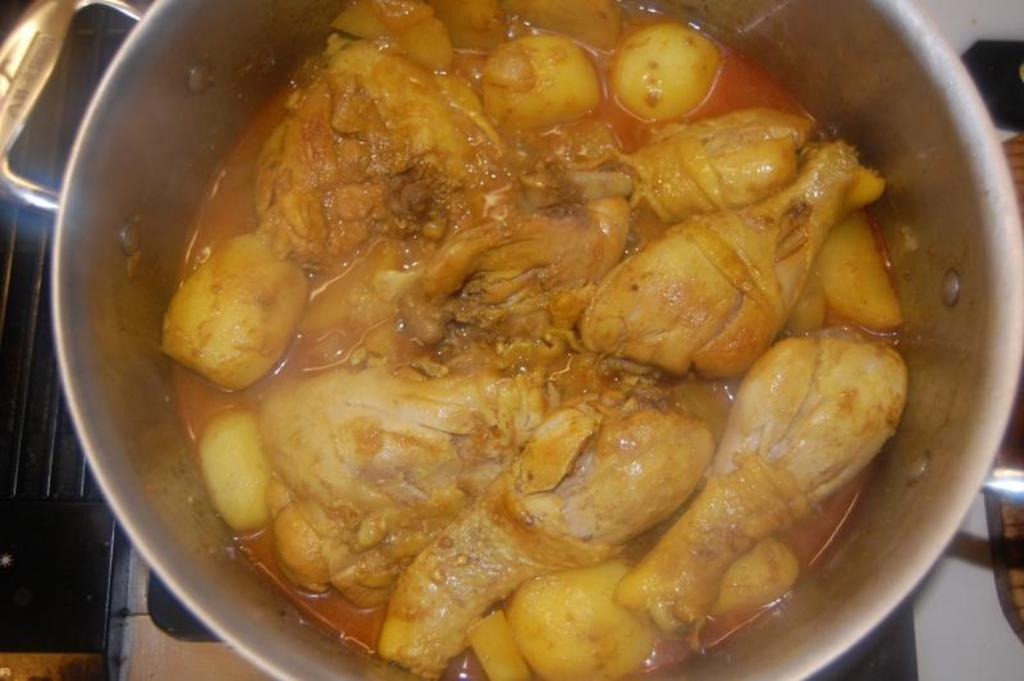What is the main object in the image? There is a vessel in the image. What is inside the vessel? The vessel contains chicken curry with potato. Can you describe any other objects in the image? There is a stove in the image. What type of mask is the squirrel wearing while sitting on the flower in the image? There is no squirrel, mask, or flower present in the image. 